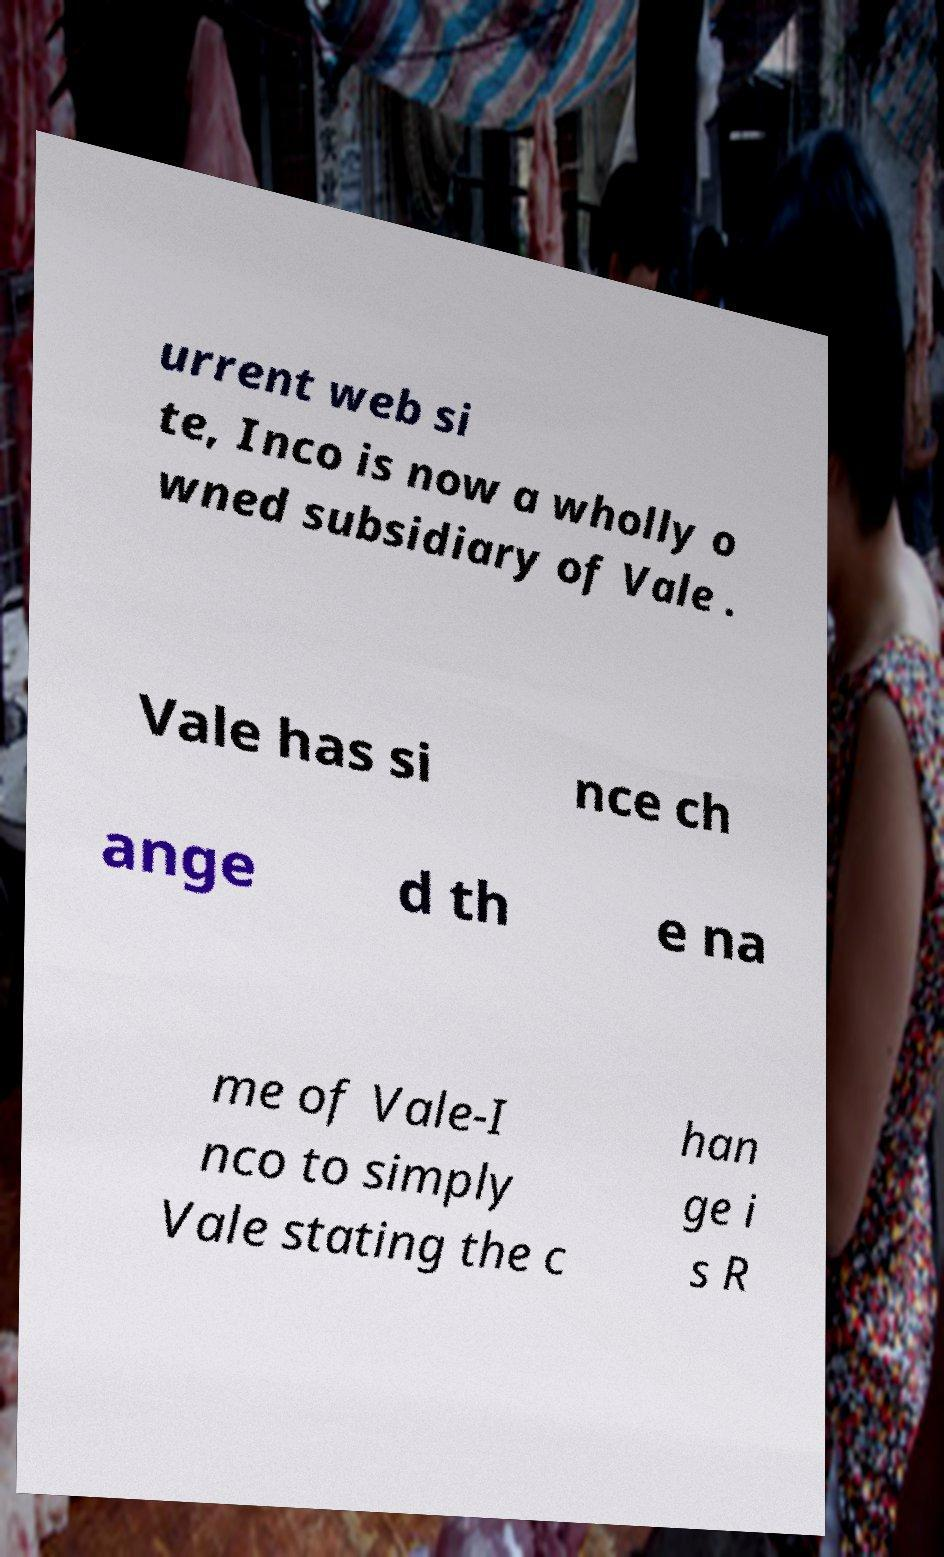Please identify and transcribe the text found in this image. urrent web si te, Inco is now a wholly o wned subsidiary of Vale . Vale has si nce ch ange d th e na me of Vale-I nco to simply Vale stating the c han ge i s R 